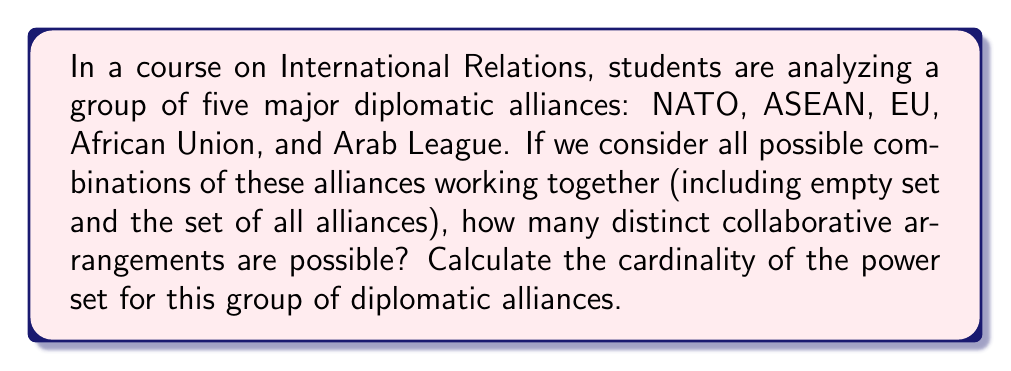Teach me how to tackle this problem. To solve this problem, we need to understand the concept of power sets and their cardinality:

1) A power set of a set $S$ is the set of all possible subsets of $S$, including the empty set and $S$ itself.

2) For a set with $n$ elements, the cardinality of its power set is given by the formula:

   $$ |P(S)| = 2^n $$

   Where $|P(S)|$ represents the cardinality of the power set of $S$.

3) In this case, we have 5 diplomatic alliances:
   $S = \{\text{NATO}, \text{ASEAN}, \text{EU}, \text{African Union}, \text{Arab League}\}$

4) Therefore, $n = 5$

5) Applying the formula:

   $$ |P(S)| = 2^5 = 32 $$

This means there are 32 possible combinations, which include:
- The empty set $\{\}$
- 5 sets with one alliance each
- 10 sets with two alliances each
- 10 sets with three alliances each
- 5 sets with four alliances each
- 1 set with all five alliances

This exhausts all possibilities, demonstrating the significance of power sets in analyzing potential collaborative arrangements in international diplomacy.
Answer: $32$ 